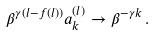Convert formula to latex. <formula><loc_0><loc_0><loc_500><loc_500>\beta ^ { \gamma ( l - f ( l ) ) } a _ { k } ^ { ( l ) } \to \beta ^ { - \gamma k } \, .</formula> 